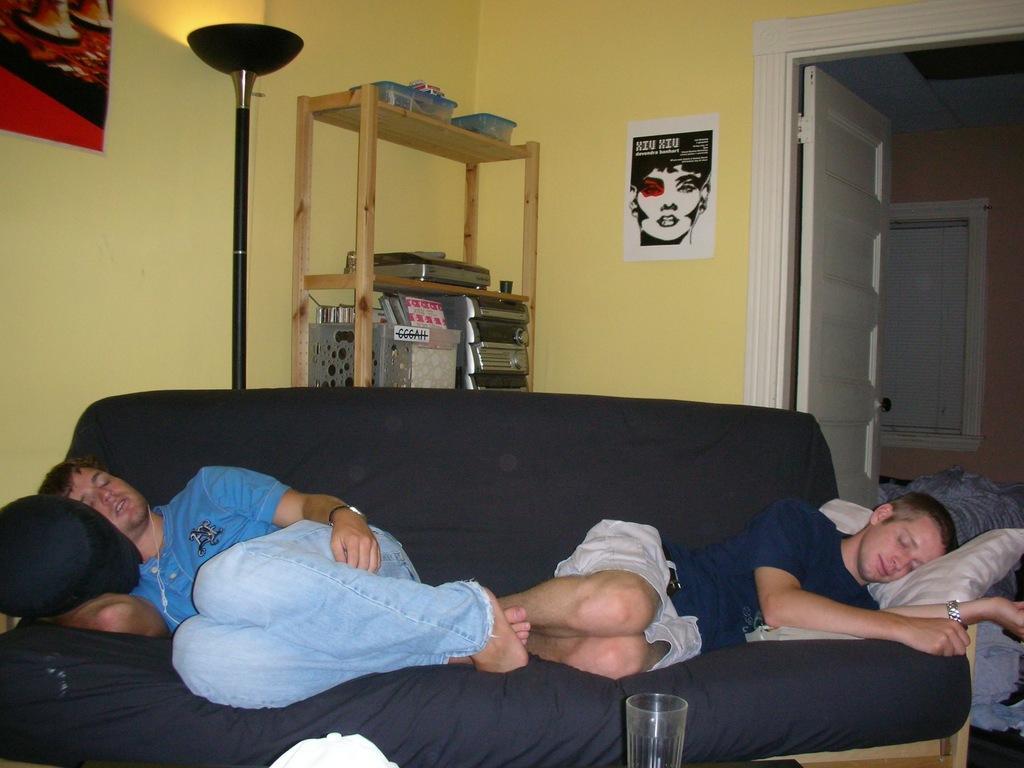How would you summarize this image in a sentence or two? In the image we can see two men wearing clothes and they are lying on the sofa. Here we can see a sofa and a glass. Behind the sofa we can see a wooden shelf and a light lamp, on the shelf, we can see there are many other objects. Here we can see posters stick to the wall and a door. 